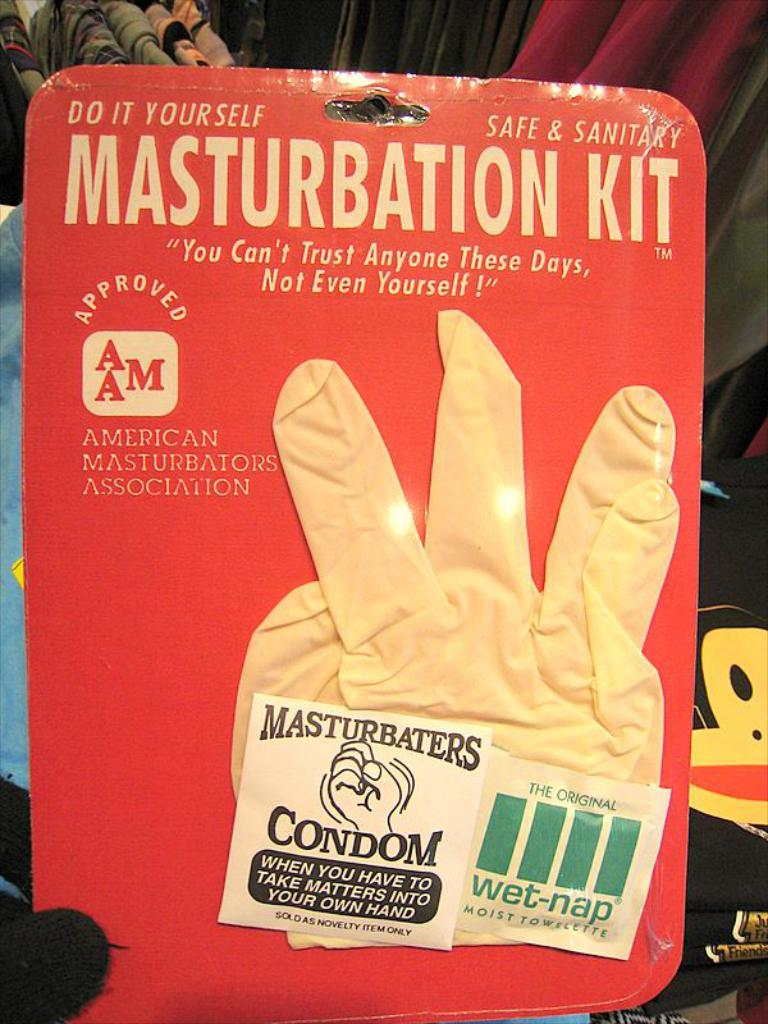<image>
Provide a brief description of the given image. A gag gift called Masturbation Kit that includes a glove. 